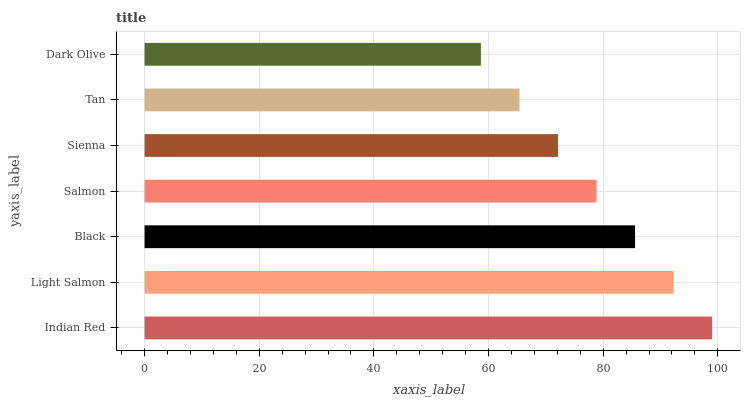Is Dark Olive the minimum?
Answer yes or no. Yes. Is Indian Red the maximum?
Answer yes or no. Yes. Is Light Salmon the minimum?
Answer yes or no. No. Is Light Salmon the maximum?
Answer yes or no. No. Is Indian Red greater than Light Salmon?
Answer yes or no. Yes. Is Light Salmon less than Indian Red?
Answer yes or no. Yes. Is Light Salmon greater than Indian Red?
Answer yes or no. No. Is Indian Red less than Light Salmon?
Answer yes or no. No. Is Salmon the high median?
Answer yes or no. Yes. Is Salmon the low median?
Answer yes or no. Yes. Is Black the high median?
Answer yes or no. No. Is Tan the low median?
Answer yes or no. No. 